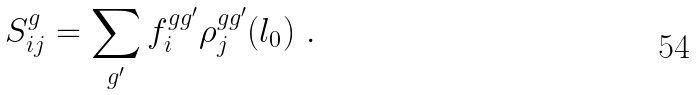Convert formula to latex. <formula><loc_0><loc_0><loc_500><loc_500>S ^ { g } _ { i j } = \sum _ { g ^ { \prime } } f ^ { g g ^ { \prime } } _ { i } \rho ^ { g g ^ { \prime } } _ { j } ( l _ { 0 } ) \ .</formula> 